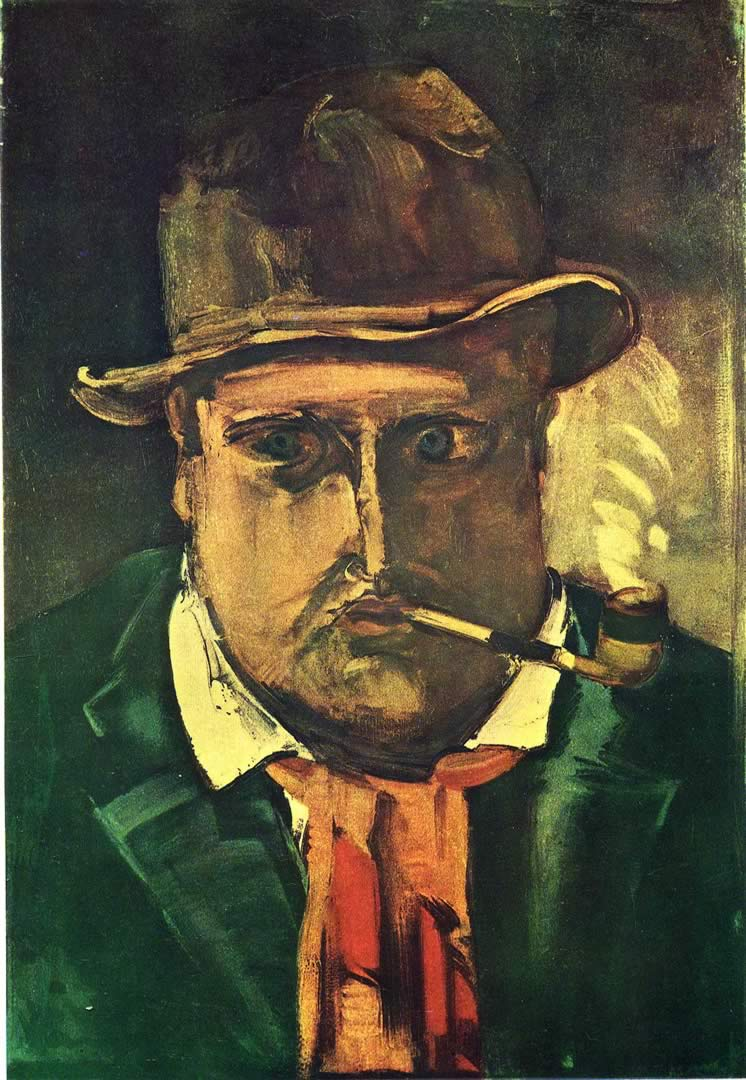What emotions do you think the artist intended to evoke with this portrayal? The artist appears to evoke feelings of melancholy and introspection. The use of shadow and the character’s haunting, direct gaze might suggest an inner turmoil or a reflective state. The rough, expressive brushwork further intensifies the emotional impact, making the viewer feel the weight of the figure's possible sorrows or deep thoughts. 